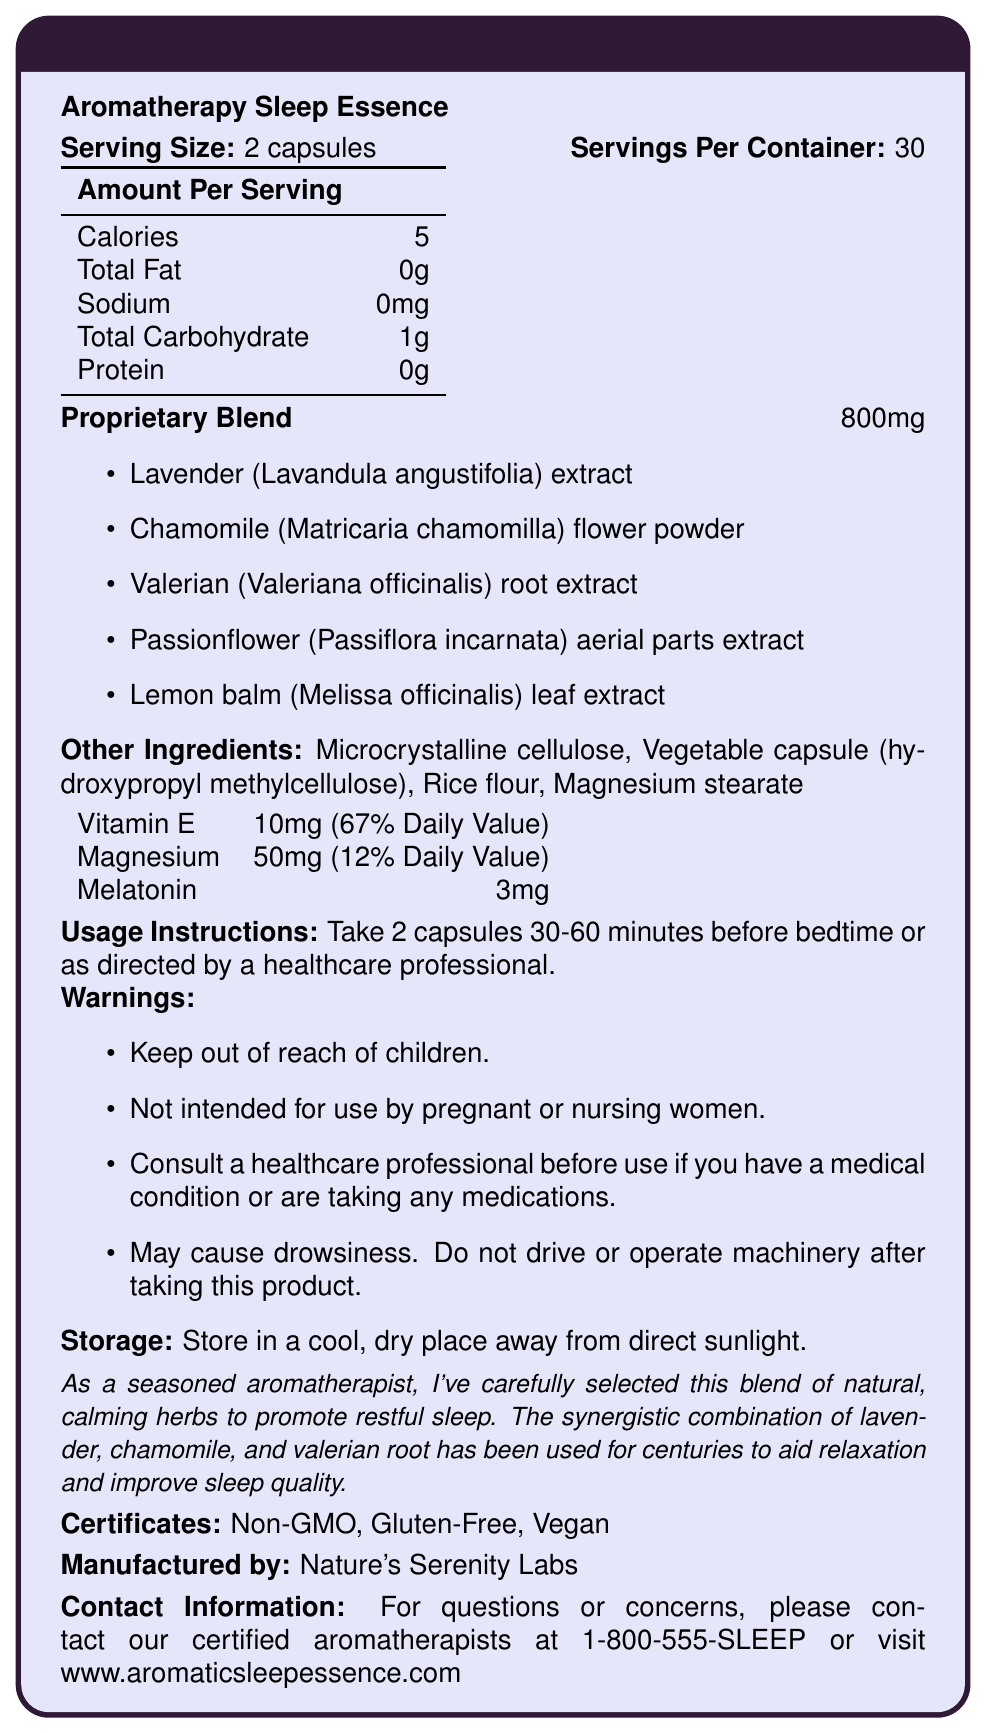What is the serving size of Aromatherapy Sleep Essence? The serving size is explicitly stated as "2 capsules".
Answer: 2 capsules How many calories are in each serving of Aromatherapy Sleep Essence? The document lists the calories per serving as 5.
Answer: 5 What is the proprietary blend amount per serving? The proprietary blend is listed as 800mg per serving.
Answer: 800mg What are the primary ingredients in the proprietary blend? These ingredients are enumerated under the "Proprietary Blend" section of the document.
Answer: Lavender extract, Chamomile flower powder, Valerian root extract, Passionflower aerial parts extract, Lemon balm leaf extract What percentage of the daily value of Vitamin E is provided in each serving? The document states that each serving provides 10mg (67% Daily Value) of Vitamin E.
Answer: 67% What is the storage recommendation for the Aromatherapy Sleep Essence? This information is listed under the "Storage" section.
Answer: Store in a cool, dry place away from direct sunlight Which of the following warnings is NOT listed on the document? A. Not intended for children B. May cause drowsiness C. Suitable for use during pregnancy D. Consult a healthcare professional The document states warnings including keeping out of reach of children, may cause drowsiness, and consulting a healthcare professional but does not mention suitability during pregnancy.
Answer: C Who manufactures Aromatherapy Sleep Essence? A. Serenity Herbs B. Nature’s Harmony Labs C. Nature’s Serenity Labs D. Aromatic Healthworks The manufacturer is explicitly stated as "Nature's Serenity Labs".
Answer: C True or False: Aromatherapy Sleep Essence is labeled as Gluten-Free. The document includes "Gluten-Free" as a certificate.
Answer: True Summarize the main purpose and contents of the document. This summary captures the essential aspects and purpose of the document based on the provided details.
Answer: The document provides detailed nutrition facts, ingredients, and usage instructions for the Aromatherapy Sleep Essence supplement. It includes information about the serving size, proprietary blend components, additional vitamins and minerals, storage recommendations, warnings, and certifications. It highlights the relaxation-promoting ingredients like lavender and chamomile. What is the customer service contact number for Nature's Serenity Labs? The contact number is given at the end of the document under "Contact Information".
Answer: 1-800-555-SLEEP How many capsules are there in one container of Aromatherapy Sleep Essence? Since there are 30 servings per container and a serving size is 2 capsules, there are 30 * 2 = 60 capsules in a container.
Answer: 60 Which ingredient in the proprietary blend is known for its calming effect and is included in this supplement? A. Echinacea B. Ginseng C. Lavender Lavender is known for its calming effects and is listed as one of the ingredients.
Answer: C Does Aromatherapy Sleep Essence contain any protein? The document states "Protein: 0g", indicating there is no protein.
Answer: No Can this document provide information about the price of the Aromatherapy Sleep Essence? The document does not provide any pricing information for the product.
Answer: Cannot be determined 